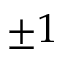<formula> <loc_0><loc_0><loc_500><loc_500>\pm 1</formula> 